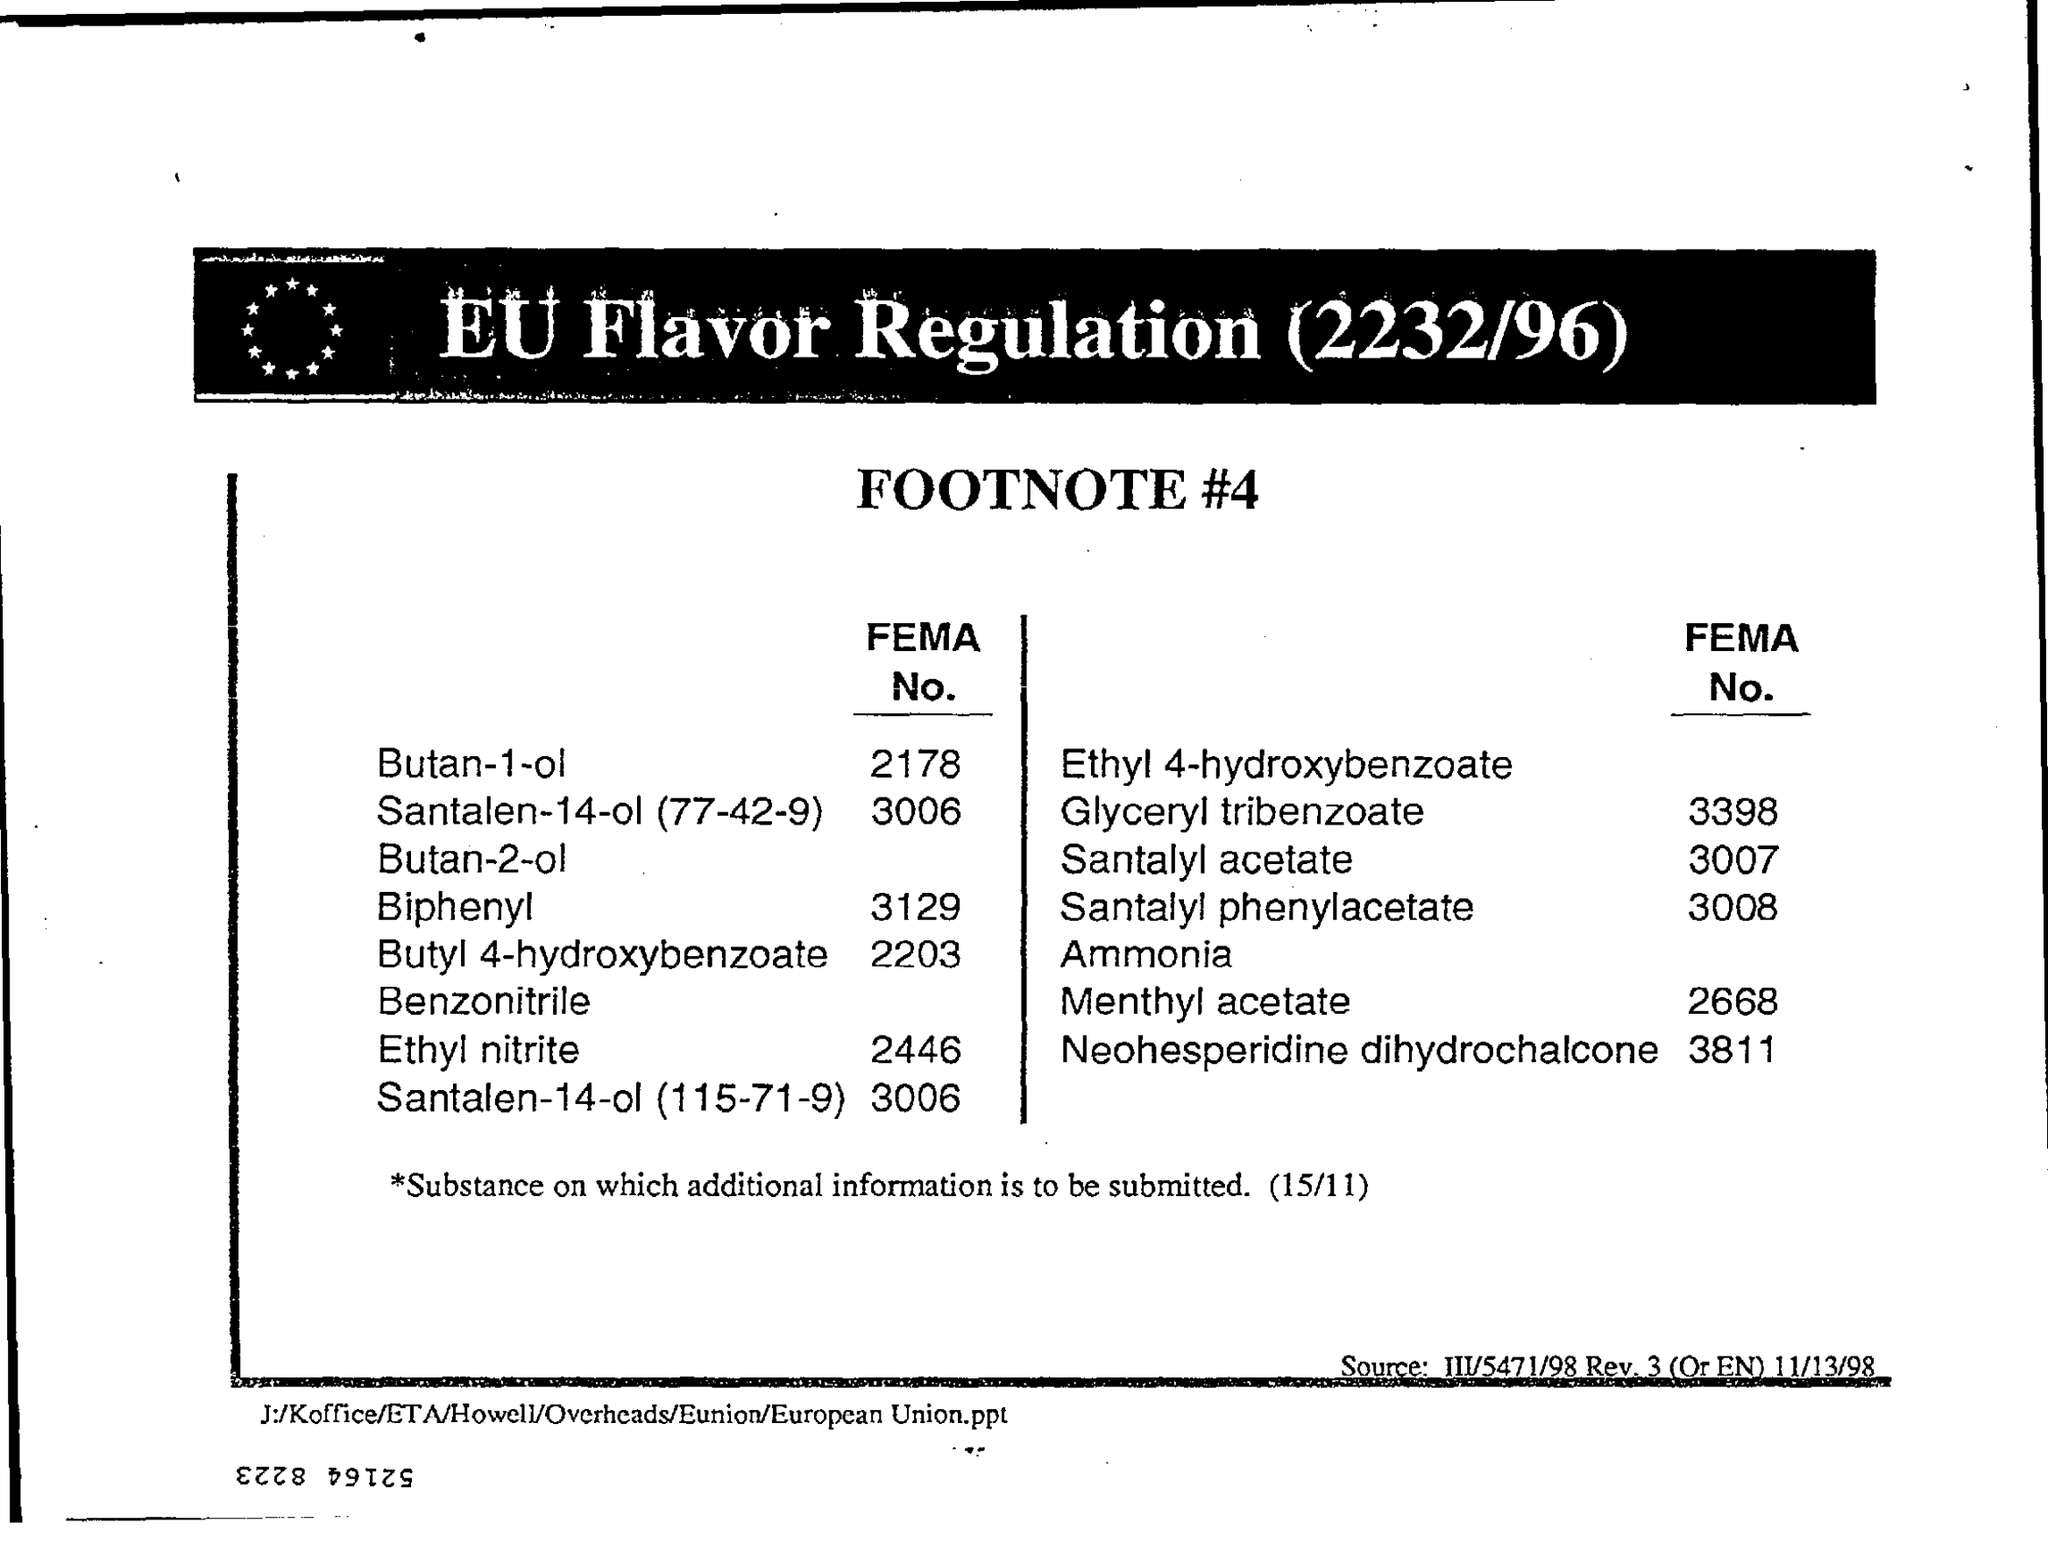What is the heading of the document?
Make the answer very short. Eu flavor regulation (2232/96). What is the FEMA No. of Menthyl acetate?
Your answer should be very brief. 2668. Whose FEMA No. is 2178?
Provide a short and direct response. Butan-1-ol. What is the sub-heading of this document?
Your response must be concise. Footnote #4. 